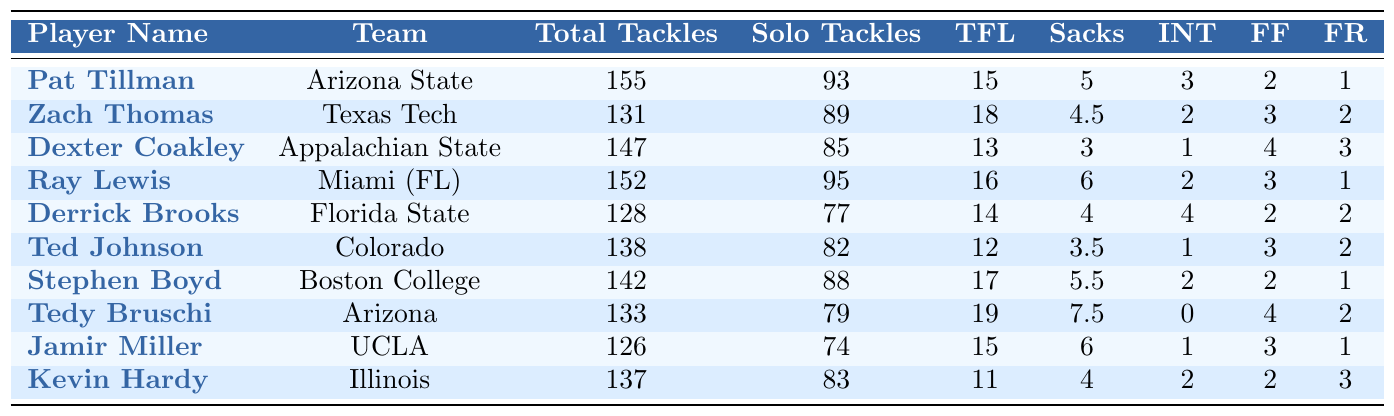What player had the highest total tackles in the 1994 NCAA Division I-AA season? By reviewing the table, I find that Pat Tillman has the highest total tackles, totaling 155.
Answer: Pat Tillman How many solo tackles did Ray Lewis achieve? The table shows that Ray Lewis had 95 solo tackles.
Answer: 95 Which player recorded the most sacks? From the table, Tedy Bruschi recorded the most sacks, with a total of 7.5.
Answer: Tedy Bruschi What is the combined number of forced fumbles and fumble recoveries for Derrick Brooks? Derrick Brooks had 2 forced fumbles and 2 fumble recoveries, so the combined total is 2 + 2 = 4.
Answer: 4 Which linebacker had the fewest total tackles among the players listed? The table indicates that Jamir Miller had the fewest total tackles with 126.
Answer: Jamir Miller On average, how many tackles for loss did the top linebackers achieve? To calculate the average, I take the total of tackles for loss: 15 + 18 + 13 + 16 + 14 + 12 + 17 + 19 + 15 + 11 = 150, then divide by the number of players, which is 10. Thus, 150/10 = 15.
Answer: 15 Is it true that Zach Thomas had more interceptions than Derrick Brooks? According to the table, Zach Thomas had 2 interceptions and Derrick Brooks had 4. Since 2 is less than 4, the statement is false.
Answer: No Who had the highest number of tackles for loss? Examining the table, I see that Tedy Bruschi recorded 19 tackles for loss, more than any other player.
Answer: Tedy Bruschi What is the difference in total tackles between Pat Tillman and Dexter Coakley? Looking at the table, Pat Tillman had 155 total tackles and Dexter Coakley had 147. The difference is 155 - 147 = 8.
Answer: 8 Which player had the lowest number of solo tackles? From the data, Jamir Miller had the lowest number of solo tackles at 74.
Answer: Jamir Miller 